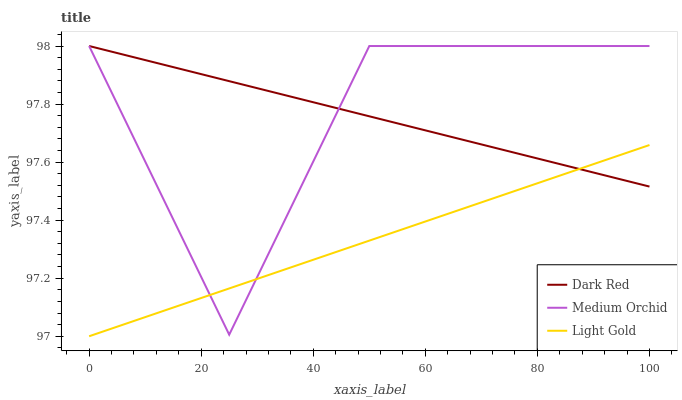Does Light Gold have the minimum area under the curve?
Answer yes or no. Yes. Does Dark Red have the maximum area under the curve?
Answer yes or no. Yes. Does Medium Orchid have the minimum area under the curve?
Answer yes or no. No. Does Medium Orchid have the maximum area under the curve?
Answer yes or no. No. Is Dark Red the smoothest?
Answer yes or no. Yes. Is Medium Orchid the roughest?
Answer yes or no. Yes. Is Light Gold the smoothest?
Answer yes or no. No. Is Light Gold the roughest?
Answer yes or no. No. Does Light Gold have the lowest value?
Answer yes or no. Yes. Does Medium Orchid have the lowest value?
Answer yes or no. No. Does Medium Orchid have the highest value?
Answer yes or no. Yes. Does Light Gold have the highest value?
Answer yes or no. No. Does Dark Red intersect Medium Orchid?
Answer yes or no. Yes. Is Dark Red less than Medium Orchid?
Answer yes or no. No. Is Dark Red greater than Medium Orchid?
Answer yes or no. No. 